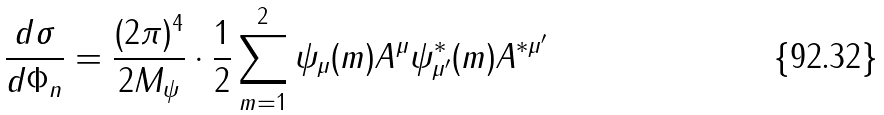<formula> <loc_0><loc_0><loc_500><loc_500>\frac { d \sigma } { d \Phi _ { n } } = \frac { ( 2 \pi ) ^ { 4 } } { 2 M _ { \psi } } \cdot \frac { 1 } { 2 } \sum ^ { 2 } _ { m = 1 } \psi _ { \mu } ( m ) A ^ { \mu } \psi ^ { * } _ { \mu ^ { \prime } } ( m ) A ^ { * \mu ^ { \prime } }</formula> 